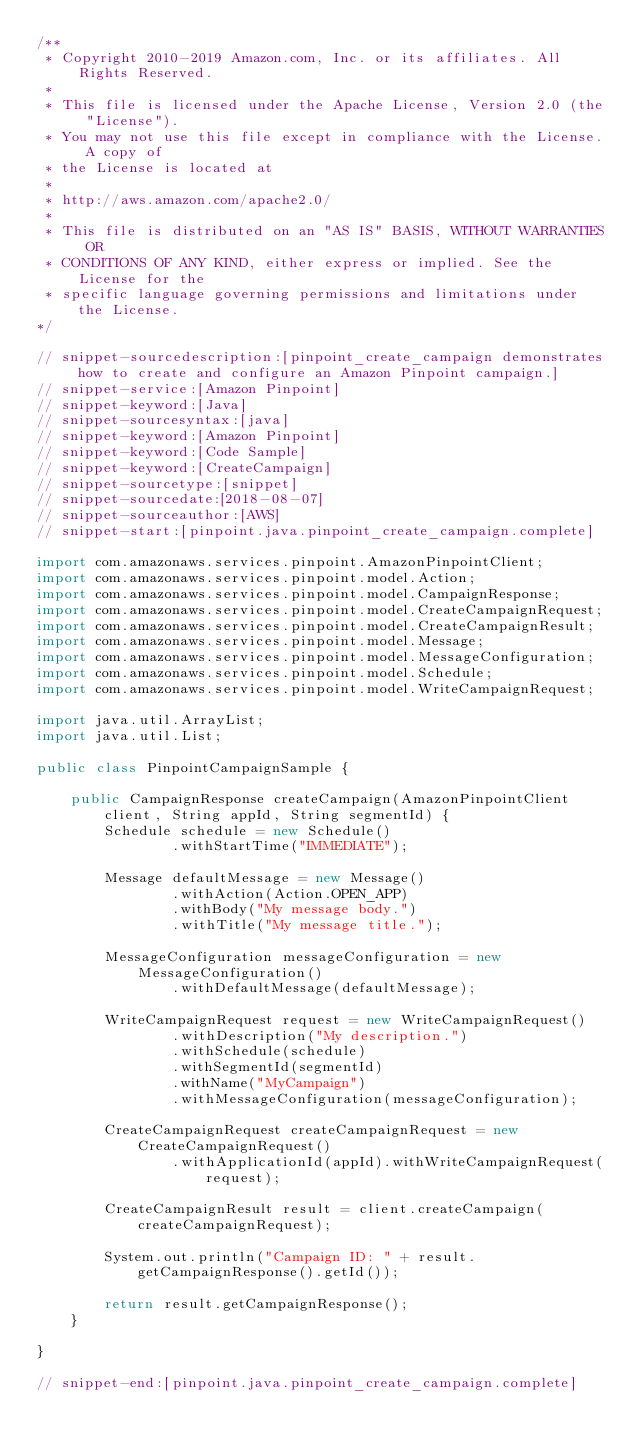<code> <loc_0><loc_0><loc_500><loc_500><_Java_>/**
 * Copyright 2010-2019 Amazon.com, Inc. or its affiliates. All Rights Reserved.
 *
 * This file is licensed under the Apache License, Version 2.0 (the "License").
 * You may not use this file except in compliance with the License. A copy of
 * the License is located at
 *
 * http://aws.amazon.com/apache2.0/
 *
 * This file is distributed on an "AS IS" BASIS, WITHOUT WARRANTIES OR
 * CONDITIONS OF ANY KIND, either express or implied. See the License for the
 * specific language governing permissions and limitations under the License.
*/

// snippet-sourcedescription:[pinpoint_create_campaign demonstrates how to create and configure an Amazon Pinpoint campaign.]
// snippet-service:[Amazon Pinpoint]
// snippet-keyword:[Java]
// snippet-sourcesyntax:[java]
// snippet-keyword:[Amazon Pinpoint]
// snippet-keyword:[Code Sample]
// snippet-keyword:[CreateCampaign]
// snippet-sourcetype:[snippet]
// snippet-sourcedate:[2018-08-07]
// snippet-sourceauthor:[AWS]
// snippet-start:[pinpoint.java.pinpoint_create_campaign.complete]

import com.amazonaws.services.pinpoint.AmazonPinpointClient;
import com.amazonaws.services.pinpoint.model.Action;
import com.amazonaws.services.pinpoint.model.CampaignResponse;
import com.amazonaws.services.pinpoint.model.CreateCampaignRequest;
import com.amazonaws.services.pinpoint.model.CreateCampaignResult;
import com.amazonaws.services.pinpoint.model.Message;
import com.amazonaws.services.pinpoint.model.MessageConfiguration;
import com.amazonaws.services.pinpoint.model.Schedule;
import com.amazonaws.services.pinpoint.model.WriteCampaignRequest;

import java.util.ArrayList;
import java.util.List;

public class PinpointCampaignSample {

    public CampaignResponse createCampaign(AmazonPinpointClient client, String appId, String segmentId) {
        Schedule schedule = new Schedule()
                .withStartTime("IMMEDIATE");

        Message defaultMessage = new Message()
                .withAction(Action.OPEN_APP)
                .withBody("My message body.")
                .withTitle("My message title.");

        MessageConfiguration messageConfiguration = new MessageConfiguration()
                .withDefaultMessage(defaultMessage);

        WriteCampaignRequest request = new WriteCampaignRequest()
                .withDescription("My description.")
                .withSchedule(schedule)
                .withSegmentId(segmentId)
                .withName("MyCampaign")
                .withMessageConfiguration(messageConfiguration);

        CreateCampaignRequest createCampaignRequest = new CreateCampaignRequest()
                .withApplicationId(appId).withWriteCampaignRequest(request);

        CreateCampaignResult result = client.createCampaign(createCampaignRequest);

        System.out.println("Campaign ID: " + result.getCampaignResponse().getId());

        return result.getCampaignResponse();
    }

}

// snippet-end:[pinpoint.java.pinpoint_create_campaign.complete]
</code> 